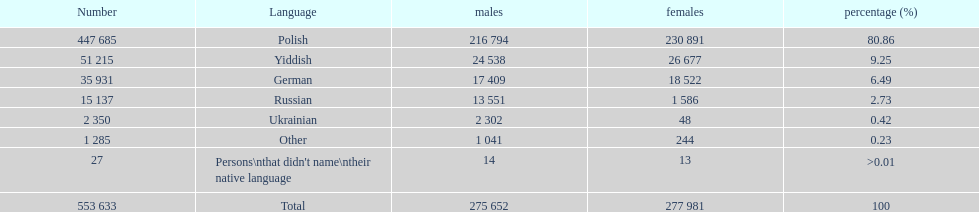Which language did the most people in the imperial census of 1897 speak in the p&#322;ock governorate? Polish. 